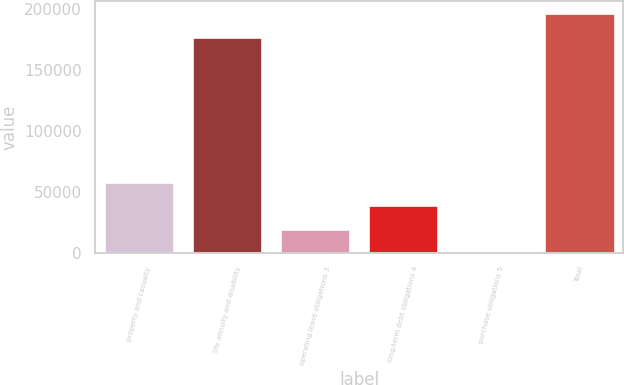Convert chart. <chart><loc_0><loc_0><loc_500><loc_500><bar_chart><fcel>property and casualty<fcel>life annuity and disability<fcel>operating lease obligations 3<fcel>long-term debt obligations 4<fcel>purchase obligations 5<fcel>Total<nl><fcel>58378.3<fcel>177548<fcel>19476.1<fcel>38927.2<fcel>25<fcel>196999<nl></chart> 